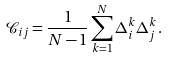Convert formula to latex. <formula><loc_0><loc_0><loc_500><loc_500>\mathcal { C } _ { i j } = \frac { 1 } { N - 1 } \sum _ { k = 1 } ^ { N } \Delta _ { i } ^ { k } \Delta _ { j } ^ { k } \, .</formula> 